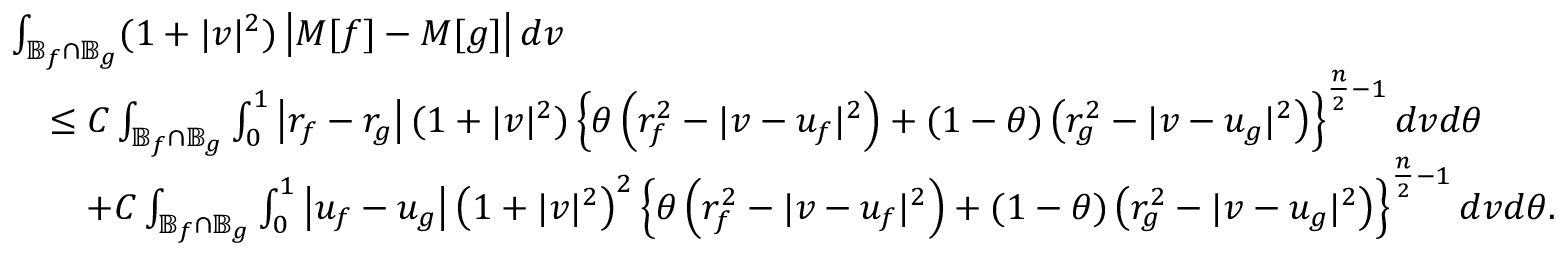Convert formula to latex. <formula><loc_0><loc_0><loc_500><loc_500>\begin{array} { r l } & { \int _ { \mathbb { B } _ { f } \cap \mathbb { B } _ { g } } ( 1 + | v | ^ { 2 } ) \left | M [ f ] - M [ g ] \right | d v } \\ & { \quad \leq C \int _ { \mathbb { B } _ { f } \cap \mathbb { B } _ { g } } \int _ { 0 } ^ { 1 } \left | r _ { f } - r _ { g } \right | ( 1 + | v | ^ { 2 } ) \left \{ \theta \left ( r _ { f } ^ { 2 } - | v - u _ { f } | ^ { 2 } \right ) + ( 1 - \theta ) \left ( r _ { g } ^ { 2 } - | v - u _ { g } | ^ { 2 } \right ) \right \} ^ { \frac { n } { 2 } - 1 } d v d \theta } \\ & { \quad + C \int _ { \mathbb { B } _ { f } \cap \mathbb { B } _ { g } } \int _ { 0 } ^ { 1 } \left | u _ { f } - u _ { g } \right | \left ( 1 + | v | ^ { 2 } \right ) ^ { 2 } \left \{ \theta \left ( r _ { f } ^ { 2 } - | v - u _ { f } | ^ { 2 } \right ) + ( 1 - \theta ) \left ( r _ { g } ^ { 2 } - | v - u _ { g } | ^ { 2 } \right ) \right \} ^ { \frac { n } { 2 } - 1 } d v d \theta . } \end{array}</formula> 